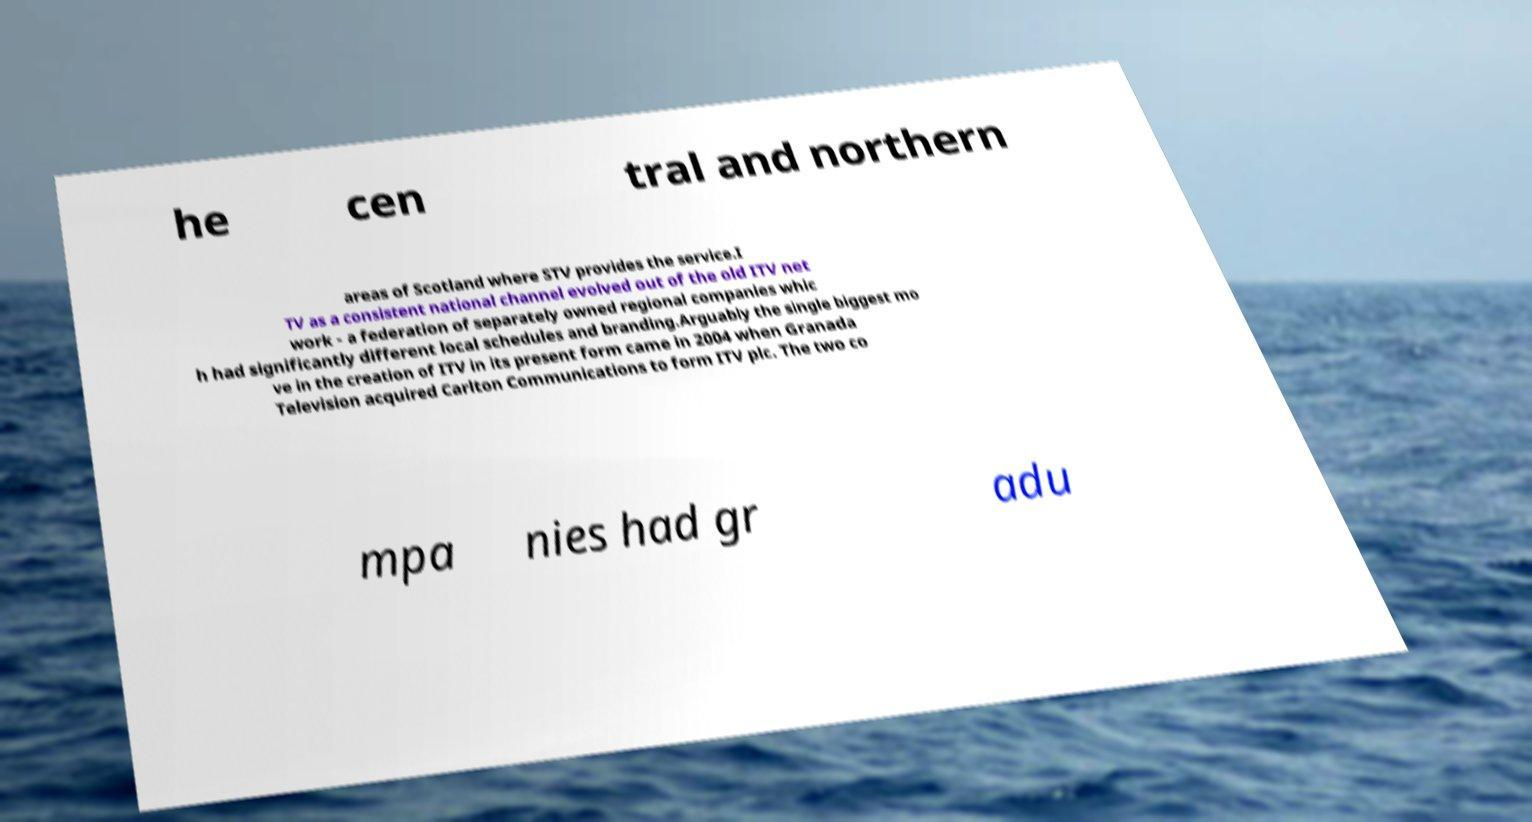Could you extract and type out the text from this image? he cen tral and northern areas of Scotland where STV provides the service.I TV as a consistent national channel evolved out of the old ITV net work - a federation of separately owned regional companies whic h had significantly different local schedules and branding.Arguably the single biggest mo ve in the creation of ITV in its present form came in 2004 when Granada Television acquired Carlton Communications to form ITV plc. The two co mpa nies had gr adu 